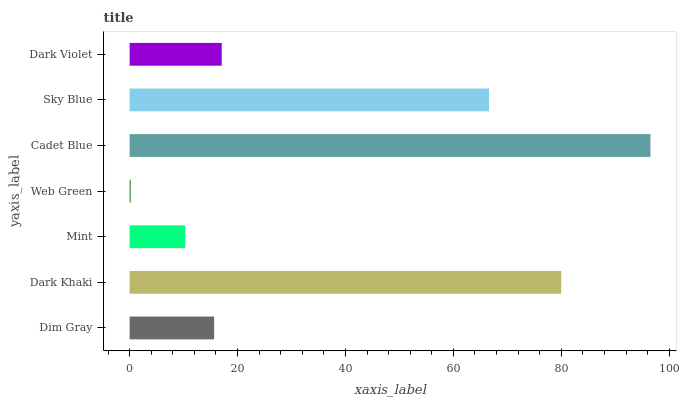Is Web Green the minimum?
Answer yes or no. Yes. Is Cadet Blue the maximum?
Answer yes or no. Yes. Is Dark Khaki the minimum?
Answer yes or no. No. Is Dark Khaki the maximum?
Answer yes or no. No. Is Dark Khaki greater than Dim Gray?
Answer yes or no. Yes. Is Dim Gray less than Dark Khaki?
Answer yes or no. Yes. Is Dim Gray greater than Dark Khaki?
Answer yes or no. No. Is Dark Khaki less than Dim Gray?
Answer yes or no. No. Is Dark Violet the high median?
Answer yes or no. Yes. Is Dark Violet the low median?
Answer yes or no. Yes. Is Dim Gray the high median?
Answer yes or no. No. Is Web Green the low median?
Answer yes or no. No. 